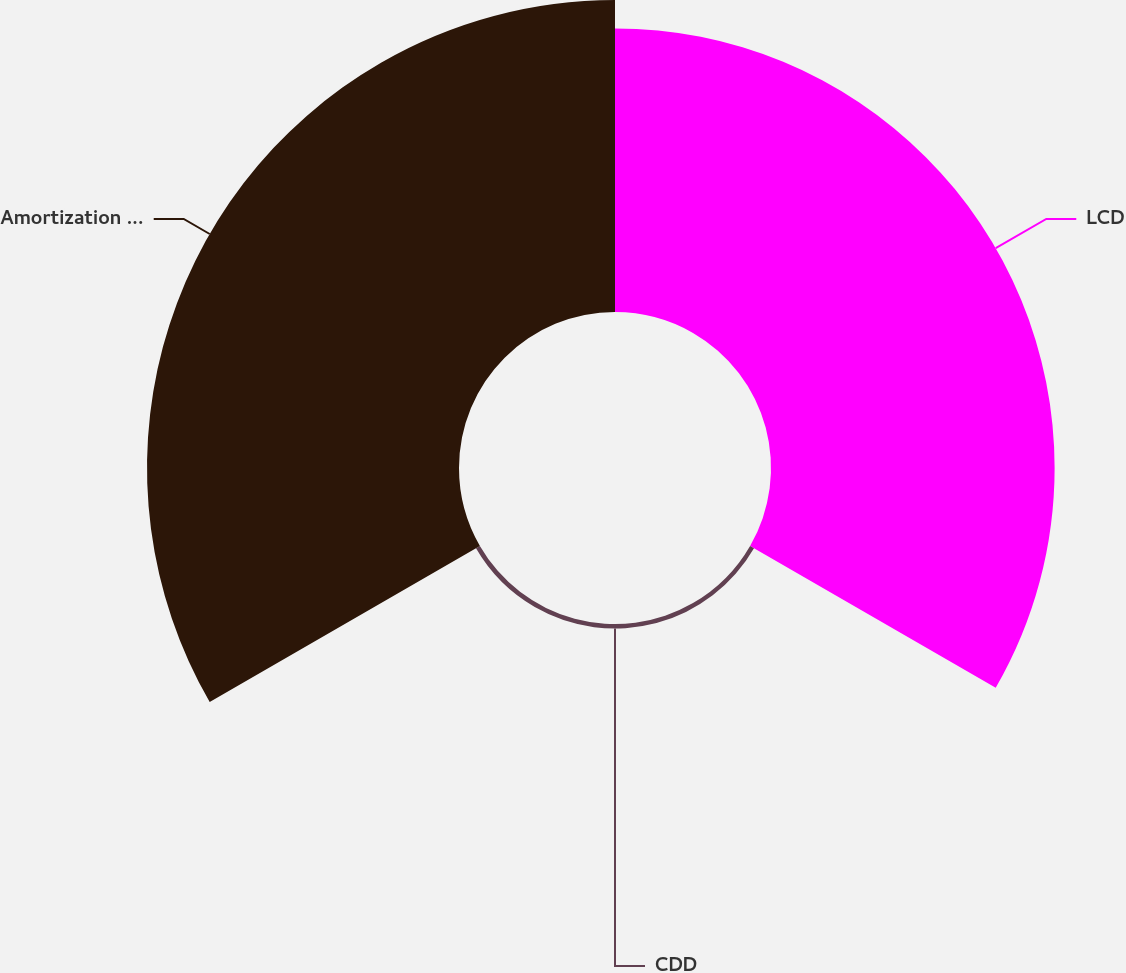Convert chart. <chart><loc_0><loc_0><loc_500><loc_500><pie_chart><fcel>LCD<fcel>CDD<fcel>Amortization of intangibles<nl><fcel>47.26%<fcel>0.75%<fcel>51.99%<nl></chart> 